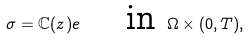Convert formula to latex. <formula><loc_0><loc_0><loc_500><loc_500>\sigma = \mathbb { C } ( z ) e \quad \text { in } \Omega \times ( 0 , T ) ,</formula> 